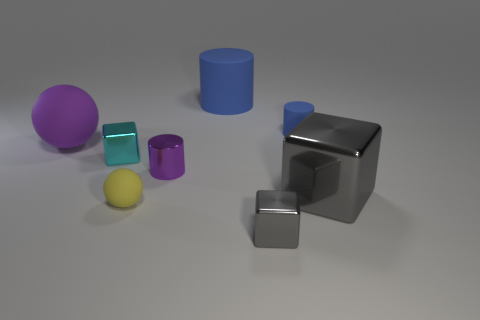Add 2 large gray metal blocks. How many objects exist? 10 Subtract all yellow balls. How many balls are left? 1 Subtract all purple cylinders. How many cylinders are left? 2 Subtract 1 blocks. How many blocks are left? 2 Subtract all red cylinders. Subtract all brown balls. How many cylinders are left? 3 Subtract all green balls. How many cyan cylinders are left? 0 Subtract all big gray cubes. Subtract all large yellow cylinders. How many objects are left? 7 Add 4 gray metal objects. How many gray metal objects are left? 6 Add 4 small cyan cubes. How many small cyan cubes exist? 5 Subtract 0 yellow blocks. How many objects are left? 8 